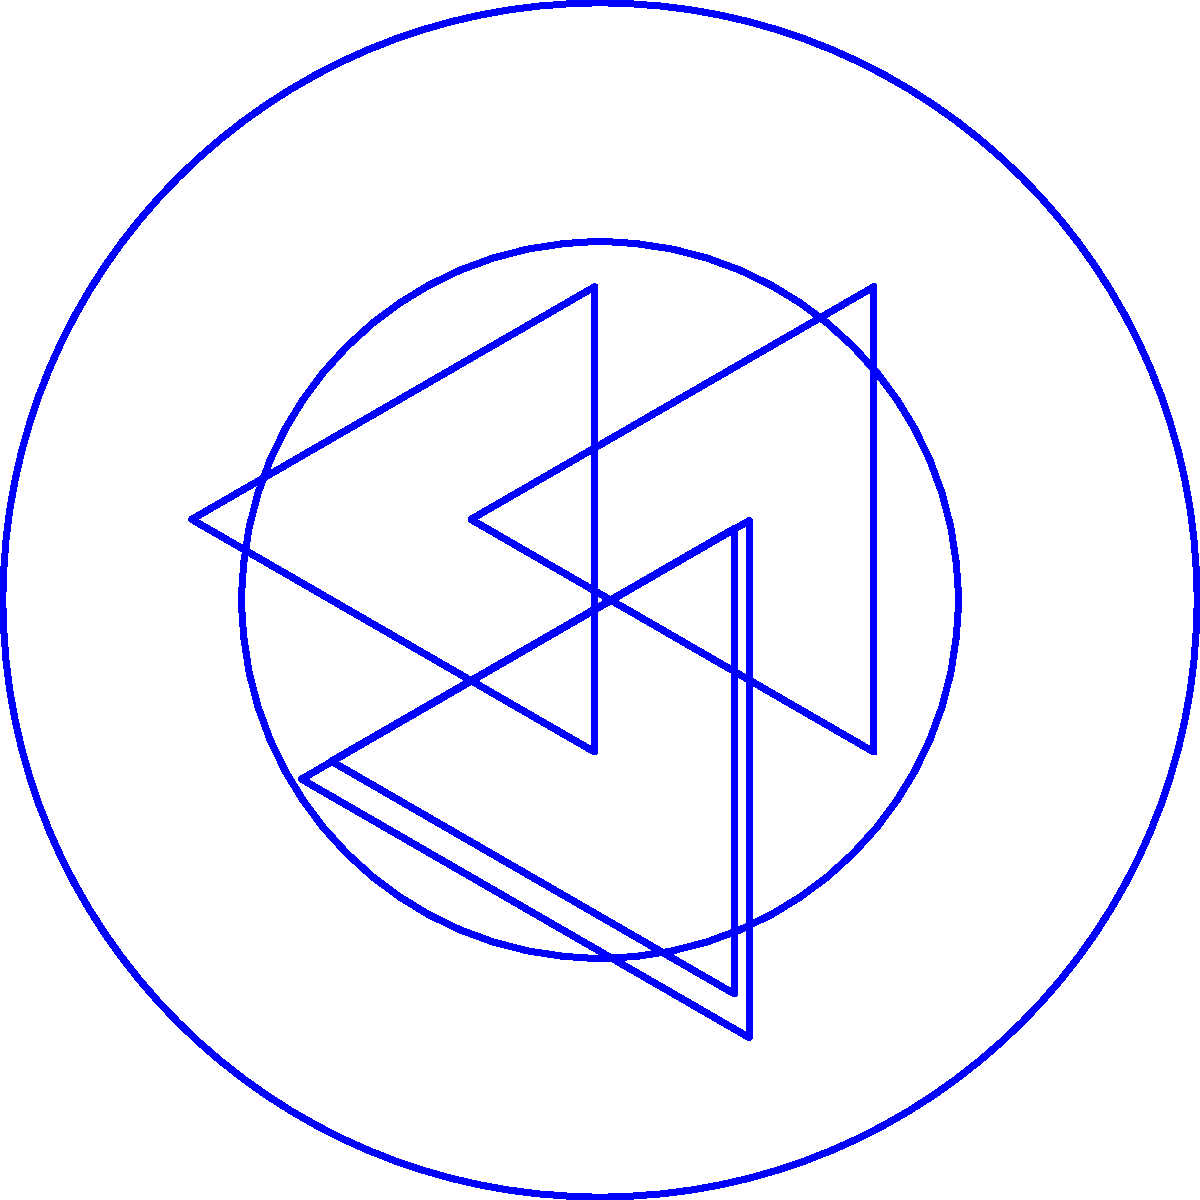Consider the simplified USL Championship logo shown above. What is the order of the rotational symmetry group of this logo? To determine the order of the rotational symmetry group, we need to identify how many distinct rotations (including the identity rotation) leave the logo unchanged. Let's analyze the logo step-by-step:

1. The outer and inner circles have infinite rotational symmetry, so they don't limit our rotations.

2. The key element determining the rotational symmetry is the arrangement of the triangles.

3. We can see that there are three triangles arranged around the center.

4. A 120° (or $\frac{2\pi}{3}$ radians) rotation will move each triangle to the position of the next one, leaving the overall logo unchanged.

5. We can perform this 120° rotation three times before returning to the original position:
   - 0° (identity)
   - 120°
   - 240°
   - 360° (back to the starting position)

6. Therefore, there are 3 distinct rotations (including the identity) that leave the logo unchanged.

7. In group theory terms, this means the rotational symmetry group of the logo is isomorphic to the cyclic group $C_3$.

The order of a group is the number of elements in the group. Here, we have identified 3 elements in the rotational symmetry group.
Answer: 3 